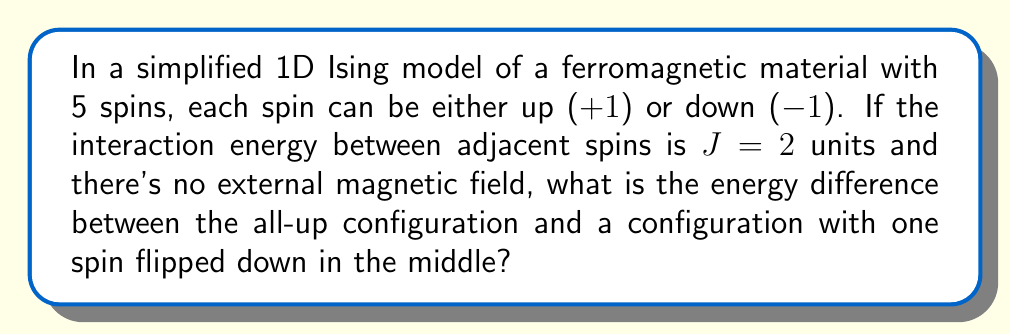Help me with this question. Let's approach this step-by-step:

1) In the Ising model, the energy of a configuration is given by:

   $$E = -J \sum_{<i,j>} s_i s_j$$

   where $<i,j>$ denotes summing over nearest neighbors.

2) For the all-up configuration (+++++):
   - There are 4 interactions between adjacent spins
   - Each interaction contributes -J to the energy (because $1 \times 1 = 1$)
   - So the total energy is: $E_1 = -4J$

3) For the configuration with one spin flipped (++−++):
   - There are still 4 interactions
   - But now, 2 interactions contribute +J (because $1 \times (-1) = -1$)
   - And 2 interactions contribute -J
   - So the total energy is: $E_2 = -2J + 2J = 0$

4) The energy difference is:
   $$\Delta E = E_2 - E_1 = 0 - (-4J) = 4J$$

5) Given that $J = 2$ units:
   $$\Delta E = 4 \times 2 = 8 \text{ units}$$
Answer: 8 units 